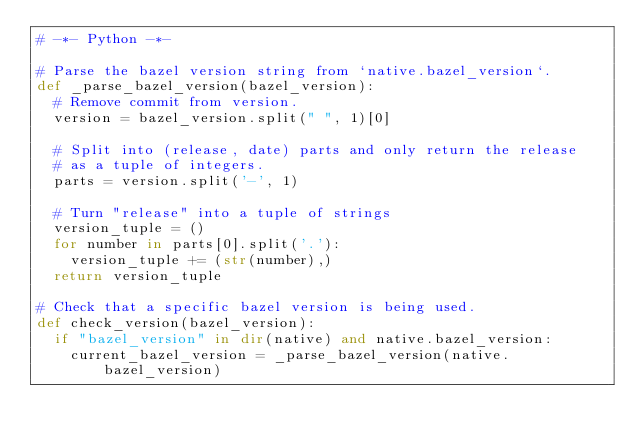Convert code to text. <code><loc_0><loc_0><loc_500><loc_500><_Python_># -*- Python -*-

# Parse the bazel version string from `native.bazel_version`.
def _parse_bazel_version(bazel_version):
  # Remove commit from version.
  version = bazel_version.split(" ", 1)[0]

  # Split into (release, date) parts and only return the release
  # as a tuple of integers.
  parts = version.split('-', 1)

  # Turn "release" into a tuple of strings
  version_tuple = ()
  for number in parts[0].split('.'):
    version_tuple += (str(number),)
  return version_tuple

# Check that a specific bazel version is being used.
def check_version(bazel_version):
  if "bazel_version" in dir(native) and native.bazel_version:
    current_bazel_version = _parse_bazel_version(native.bazel_version)</code> 